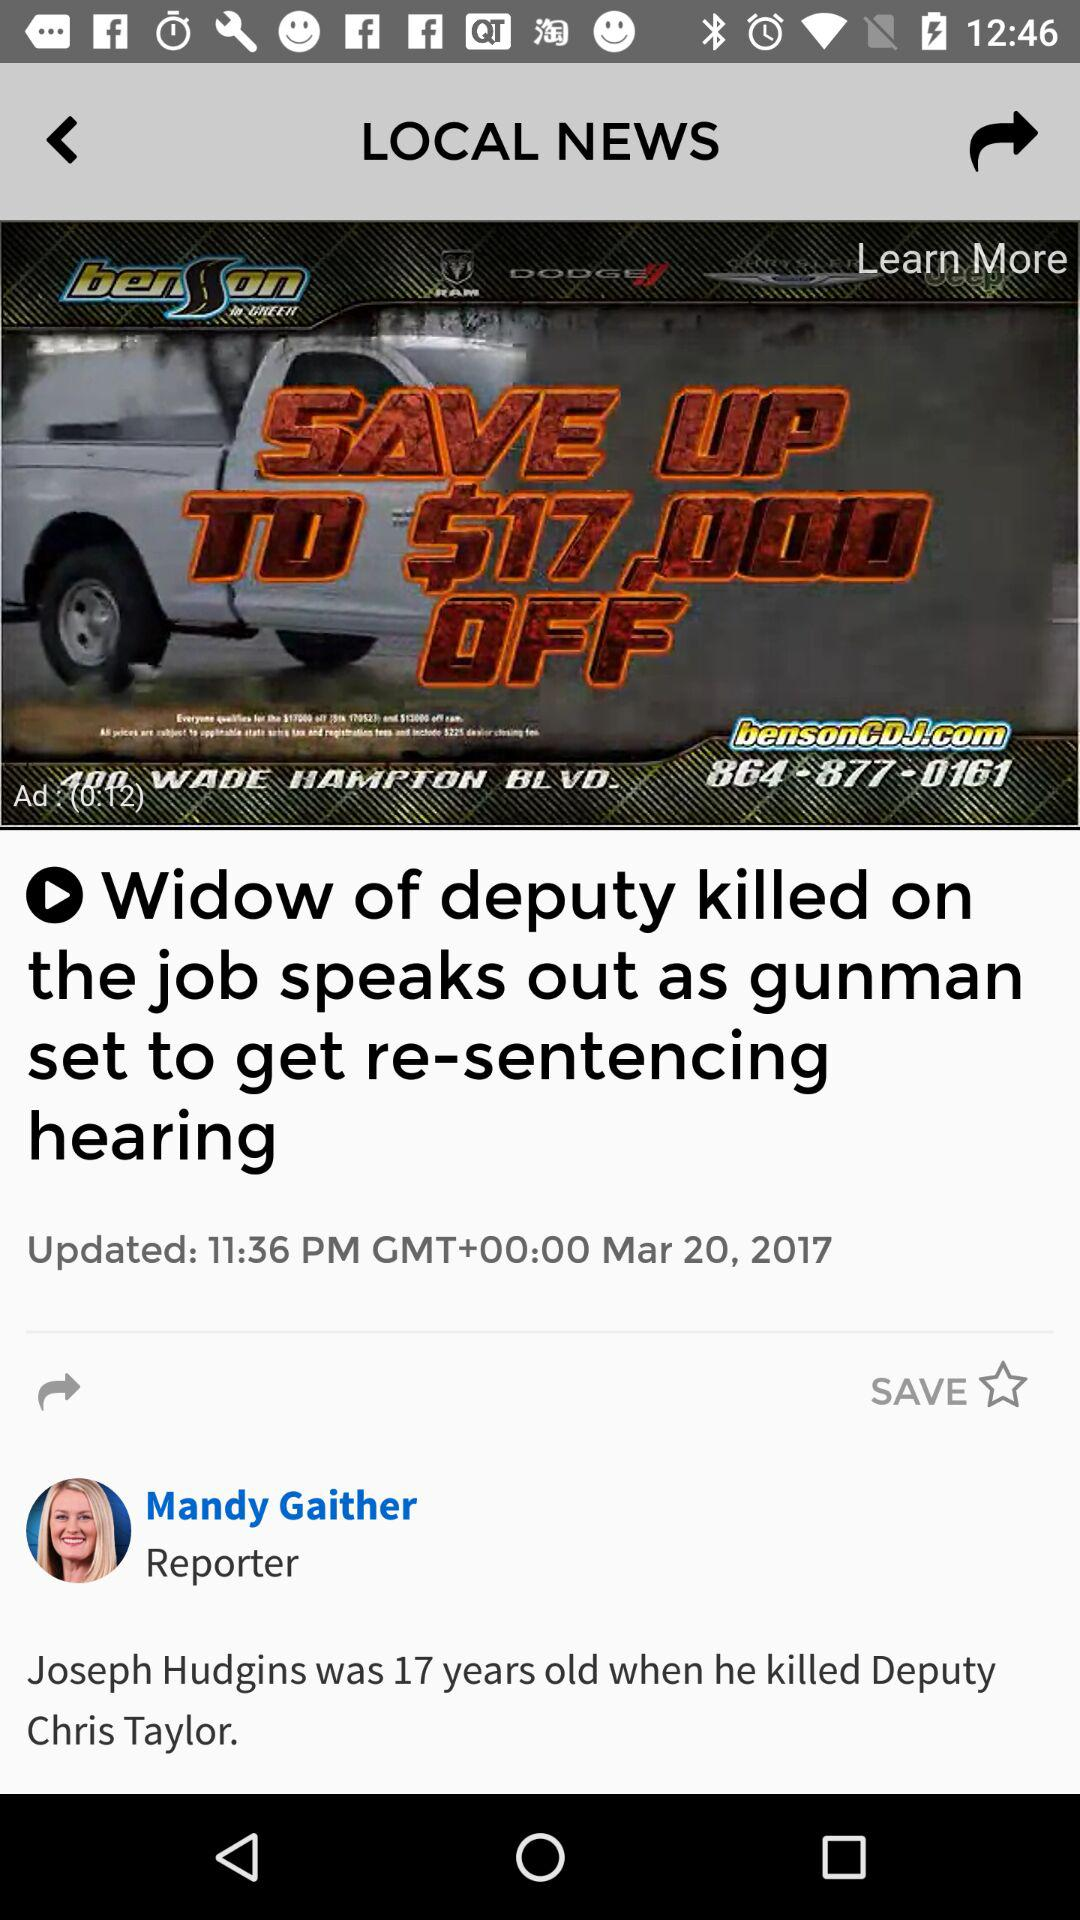In which city is "benson" located?
When the provided information is insufficient, respond with <no answer>. <no answer> 